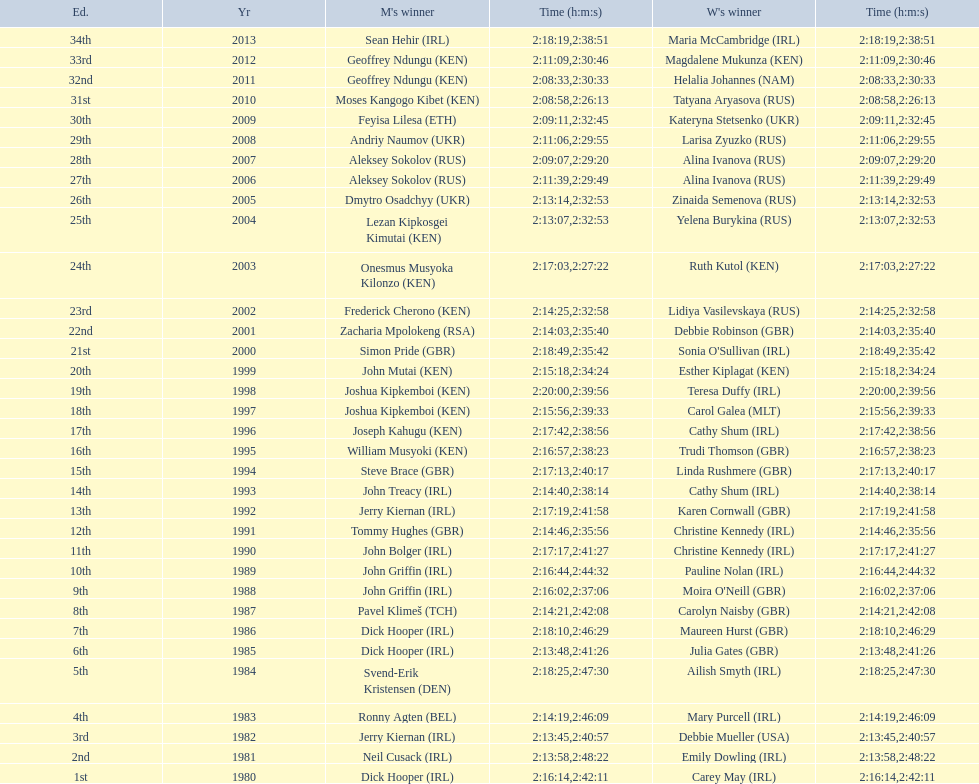Who won after joseph kipkemboi's winning streak ended? John Mutai (KEN). 